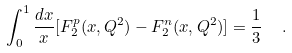Convert formula to latex. <formula><loc_0><loc_0><loc_500><loc_500>\int _ { 0 } ^ { 1 } \frac { d x } { x } [ F _ { 2 } ^ { p } ( x , Q ^ { 2 } ) - F _ { 2 } ^ { n } ( x , Q ^ { 2 } ) ] = \frac { 1 } { 3 } \ \ .</formula> 